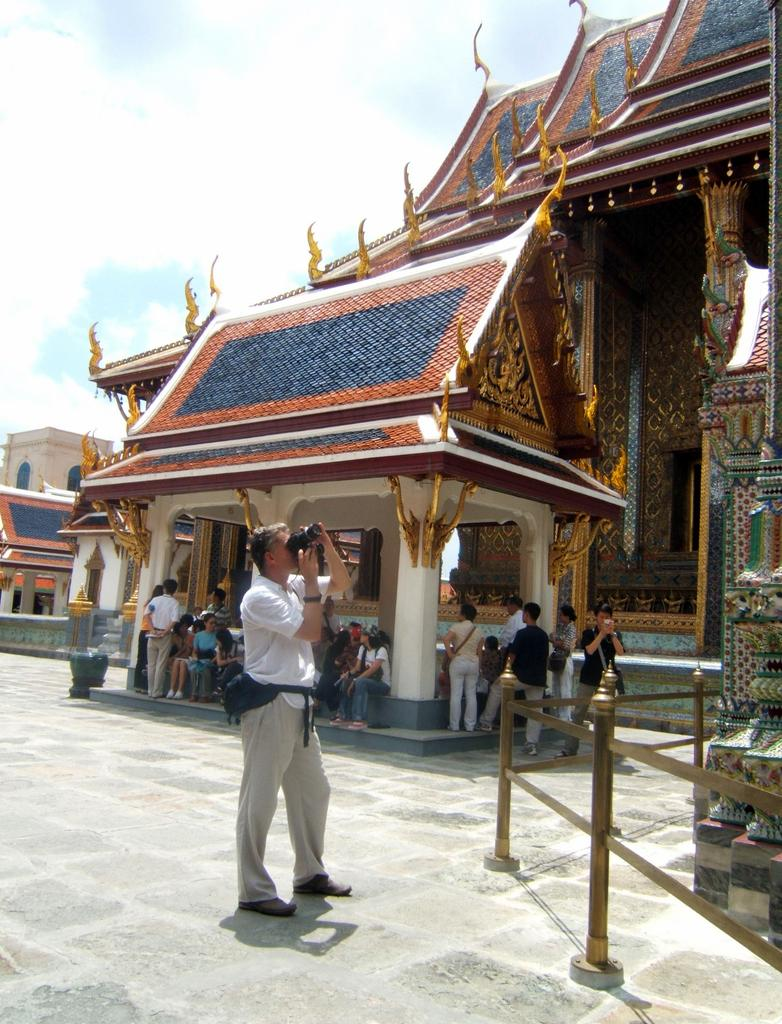What is the main subject of the image? The main subject of the image is an architecture. What is the person in the image doing? The person is taking a photograph of the architecture. Can you describe the group of people in the image? There is a group of people sitting under a roof in the image. What type of impulse can be seen affecting the architecture in the image? There is no impulse affecting the architecture in the image; it is a static structure. Can you tell me how many marks are visible on the architecture in the image? There are no marks visible on the architecture in the image. 